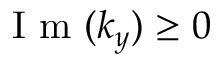Convert formula to latex. <formula><loc_0><loc_0><loc_500><loc_500>I m ( k _ { y } ) \geq 0</formula> 